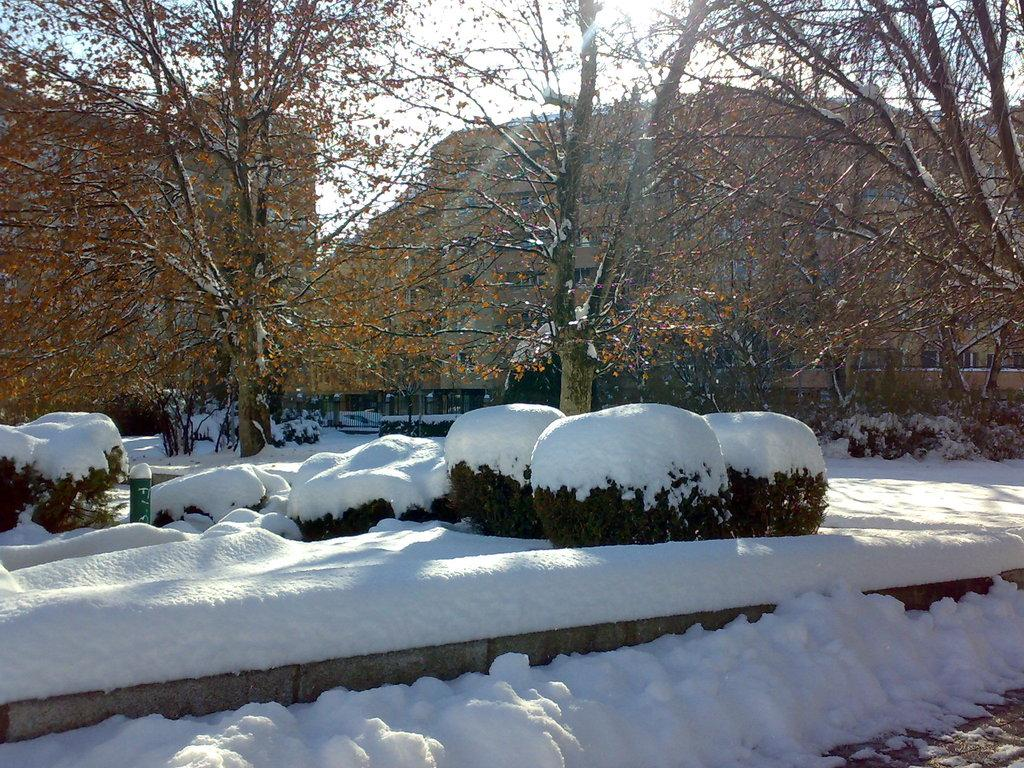What is the condition of the plants in the image? The plants in the image are covered with snow. What can be seen in the background of the image? There are many trees and houses in the background of the image. What is visible in the sky in the image? The sky is visible in the background of the image. How does the rat express regret in the image? There is no rat present in the image, and therefore no expression of regret can be observed. 